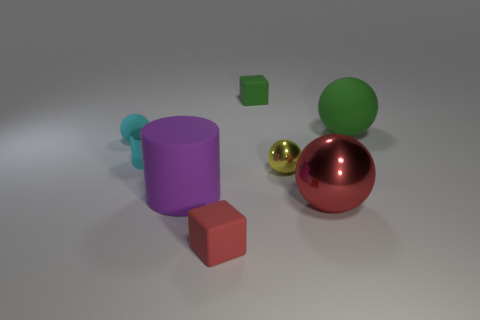Subtract 2 balls. How many balls are left? 2 Subtract all green balls. How many balls are left? 3 Add 2 large cyan metallic balls. How many objects exist? 10 Subtract all purple spheres. Subtract all purple blocks. How many spheres are left? 4 Subtract all blocks. How many objects are left? 6 Subtract all big metal things. Subtract all tiny red rubber things. How many objects are left? 6 Add 1 small green matte cubes. How many small green matte cubes are left? 2 Add 5 large metallic balls. How many large metallic balls exist? 6 Subtract 1 cyan balls. How many objects are left? 7 